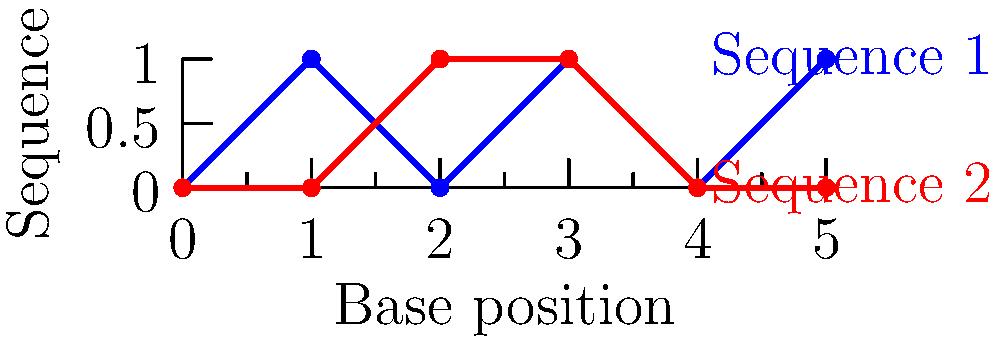As a pediatrics-focused med student, you're studying genetic disorders common in children. Your esteemed professor has presented you with two DNA sequences from a patient suspected of having a specific genetic disorder. The sequences are represented in the graph above, where each point indicates a base difference from a reference sequence. What is the length of the longest congruent subsequence between these two DNA strands? To solve this problem, we need to follow these steps:

1. Understand the representation: Each point on the graph represents a base that differs from a reference sequence. The x-axis shows the position of the base, and the y-axis distinguishes between the two sequences.

2. Compare the sequences:
   - At position 0: Both sequences match (both have a point)
   - At position 1: Sequences differ (Sequence 1 has a point, Sequence 2 doesn't)
   - At position 2: Sequences differ (Sequence 2 has a point, Sequence 1 doesn't)
   - At position 3: Both sequences match (both have a point)
   - At position 4: Both sequences match (neither has a point)
   - At position 5: Sequences differ (Sequence 1 has a point, Sequence 2 doesn't)

3. Identify congruent subsequences:
   - There's a congruent subsequence of length 1 at position 0
   - There's a congruent subsequence of length 2 from position 3 to 4

4. Determine the longest congruent subsequence:
   The longest congruent subsequence is from position 3 to 4, with a length of 2.

This analysis is crucial in pediatric genetics, as it helps identify matching segments in DNA sequences, which can be indicative of specific genetic disorders or inherited traits in children.
Answer: 2 